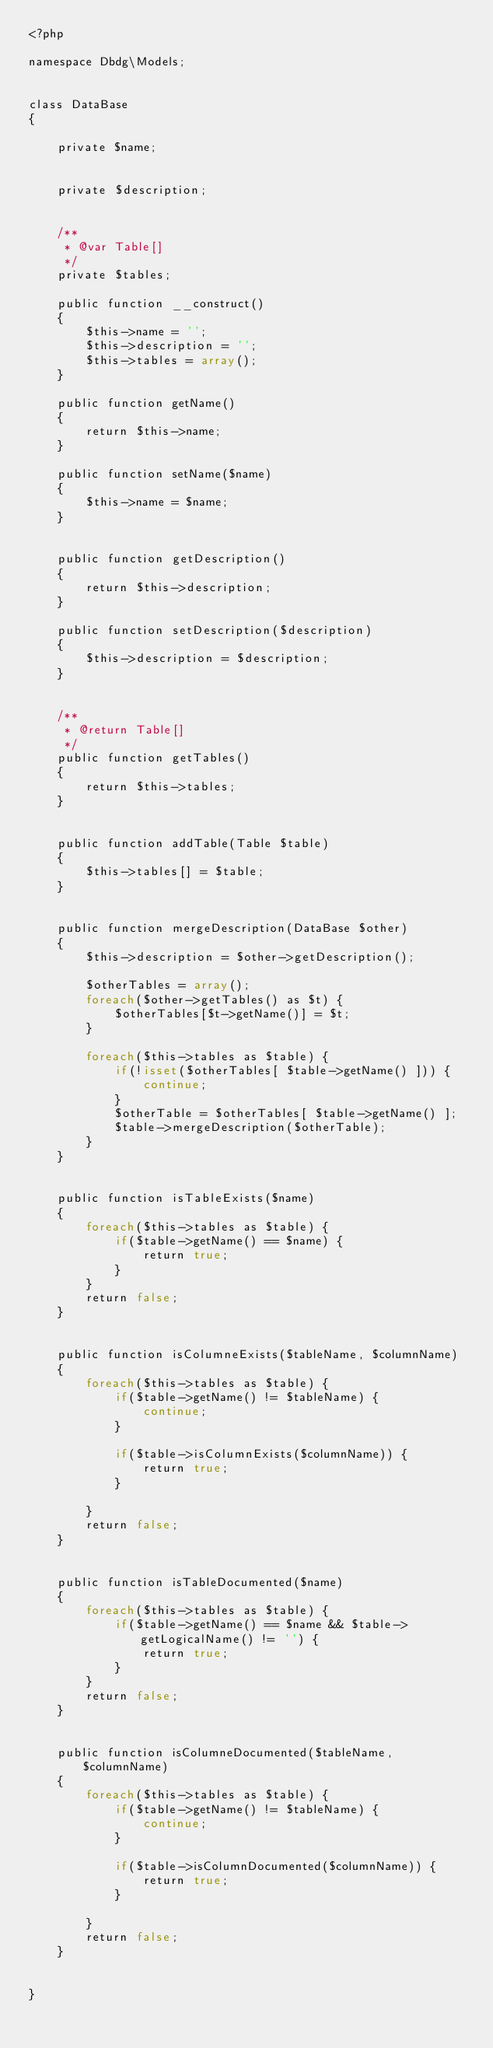<code> <loc_0><loc_0><loc_500><loc_500><_PHP_><?php

namespace Dbdg\Models;


class DataBase
{

    private $name;


    private $description;


    /**
     * @var Table[]
     */
    private $tables;

    public function __construct()
    {
        $this->name = '';
        $this->description = '';
        $this->tables = array();
    }

    public function getName()
    {
        return $this->name;
    }

    public function setName($name)
    {
        $this->name = $name;
    }


    public function getDescription()
    {
        return $this->description;
    }

    public function setDescription($description)
    {
        $this->description = $description;
    }


    /**
     * @return Table[]
     */
    public function getTables()
    {
        return $this->tables;
    }


    public function addTable(Table $table)
    {
        $this->tables[] = $table;
    }


    public function mergeDescription(DataBase $other)
    {
        $this->description = $other->getDescription();

        $otherTables = array();
        foreach($other->getTables() as $t) {
            $otherTables[$t->getName()] = $t;
        }

        foreach($this->tables as $table) {
            if(!isset($otherTables[ $table->getName() ])) {
                continue;
            }
            $otherTable = $otherTables[ $table->getName() ];
            $table->mergeDescription($otherTable);
        }
    }


    public function isTableExists($name)
    {
        foreach($this->tables as $table) {
            if($table->getName() == $name) {
                return true;
            }
        }
        return false;
    }


    public function isColumneExists($tableName, $columnName)
    {
        foreach($this->tables as $table) {
            if($table->getName() != $tableName) {
                continue;
            }

            if($table->isColumnExists($columnName)) {
                return true;
            }

        }
        return false;
    }


    public function isTableDocumented($name)
    {
        foreach($this->tables as $table) {
            if($table->getName() == $name && $table->getLogicalName() != '') {
                return true;
            }
        }
        return false;
    }


    public function isColumneDocumented($tableName, $columnName)
    {
        foreach($this->tables as $table) {
            if($table->getName() != $tableName) {
                continue;
            }

            if($table->isColumnDocumented($columnName)) {
                return true;
            }

        }
        return false;
    }


}
</code> 